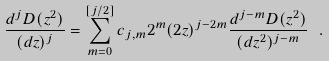<formula> <loc_0><loc_0><loc_500><loc_500>\frac { d ^ { j } D ( z ^ { 2 } ) } { ( d z ) ^ { j } } = \sum _ { m = 0 } ^ { [ j / 2 ] } c _ { j , m } 2 ^ { m } ( 2 z ) ^ { j - 2 m } \frac { d ^ { j - m } D ( z ^ { 2 } ) } { ( d z ^ { 2 } ) ^ { j - m } } \ .</formula> 